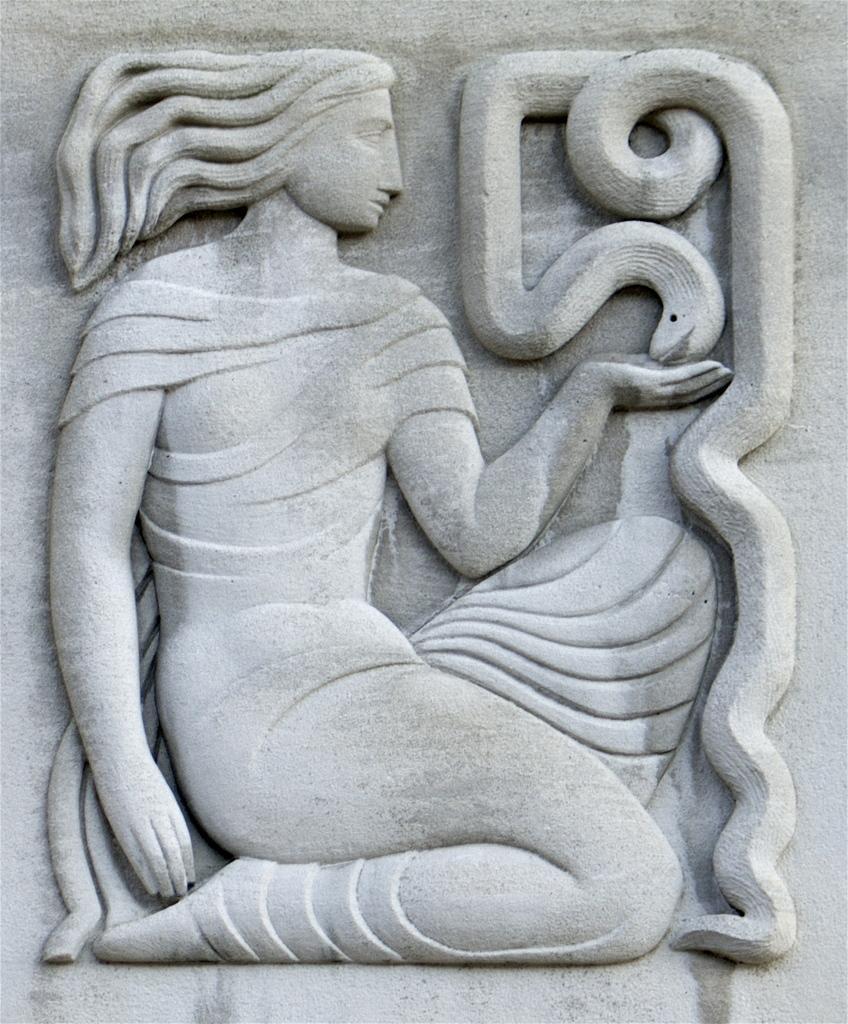In one or two sentences, can you explain what this image depicts? In this image we can see the sculpture of a woman and also the snake. 